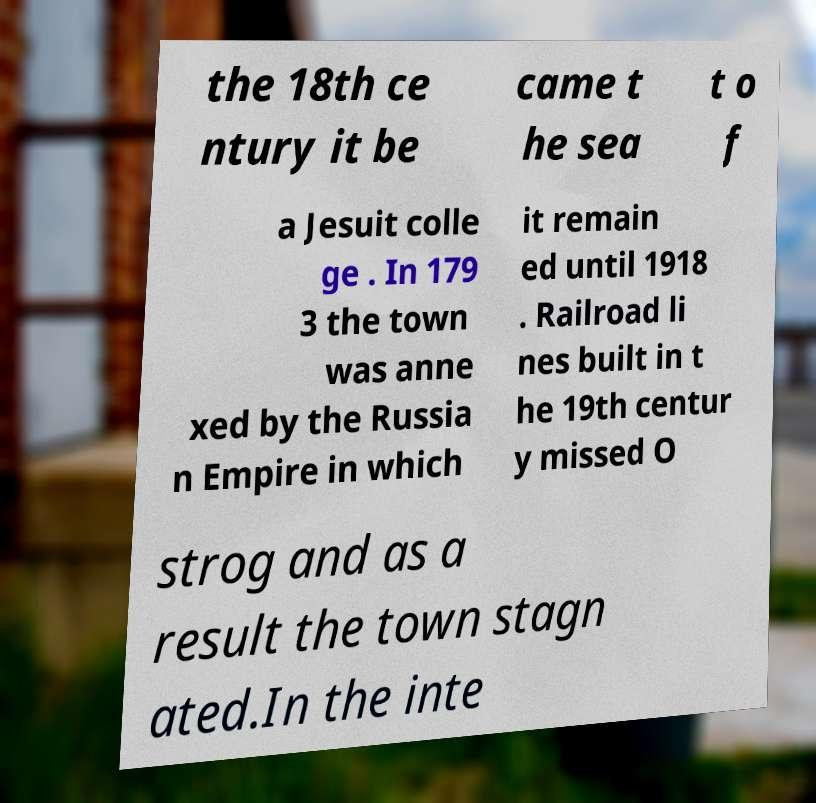Please read and relay the text visible in this image. What does it say? the 18th ce ntury it be came t he sea t o f a Jesuit colle ge . In 179 3 the town was anne xed by the Russia n Empire in which it remain ed until 1918 . Railroad li nes built in t he 19th centur y missed O strog and as a result the town stagn ated.In the inte 